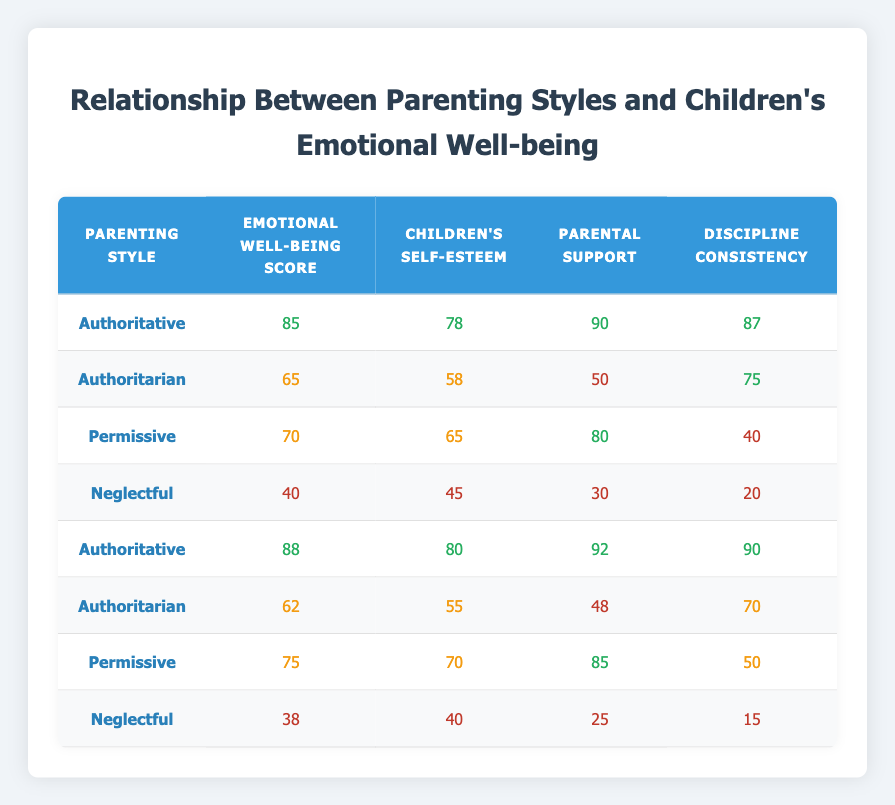What is the Emotional Well-Being Score for the Authoritative parenting style? The Emotional Well-Being Score for the Authoritative parenting style can be found by looking at the rows that list this parenting style. The first score is 85, and the second score is 88. The scores for Authoritative are 85 and 88.
Answer: 85, 88 What is the average Emotional Well-Being Score across all parenting styles? To find the average, we need to sum all Emotional Well-Being Scores: 85 + 65 + 70 + 40 + 88 + 62 + 75 + 38 = 513. There are 8 parenting styles, so we divide: 513 / 8 = 64.125.
Answer: 64.13 Is the Children's Self-Esteem score higher for Permissive or Authoritarian parenting styles? For the Permissive parenting style, the Children's Self-Esteem score is 65. For Authoritarian, it is 58. Since 65 is greater than 58, the Permissive style has a higher score.
Answer: Yes What is the difference in Children’s Self-Esteem scores between the Neglectful and Authoritative parenting styles? The Children's Self-Esteem score for Neglectful is 45, and for Authoritative, the highest score is 80. To find the difference, we subtract: 80 - 45 = 35.
Answer: 35 How many parenting styles have an Emotional Well-Being Score that is less than 60? By examining the table, the Emotional Well-Being Scores less than 60 are 65, 62, 40, and 38. This means that the Authoritarian and Neglectful parenting styles have scores below 60. That gives us 3 styles.
Answer: 2 Which Parenting Style has the highest Discipline Consistency score? Looking at the Discipline Consistency column, the scores are 87, 75, 40, 20, 90, 70, 50, and 15. The highest score is 90, corresponding to Authoritative parenting style.
Answer: Authoritative Is there a Parenting Style with a perfect score in Parental Support? In the Parental Support column, the highest score is 92, which belongs to Authoritative as well. However, there are no perfect scores of 100 in the table.
Answer: No What Parenting Style has the lowest Emotional Well-Being Score, and what is that score? The lowest Emotional Well-Being Score is found by checking the scores: 85, 65, 70, 40, 88, 62, 75, and 38. The lowest score is 38 belonging to the Neglectful parenting style.
Answer: Neglectful, 38 